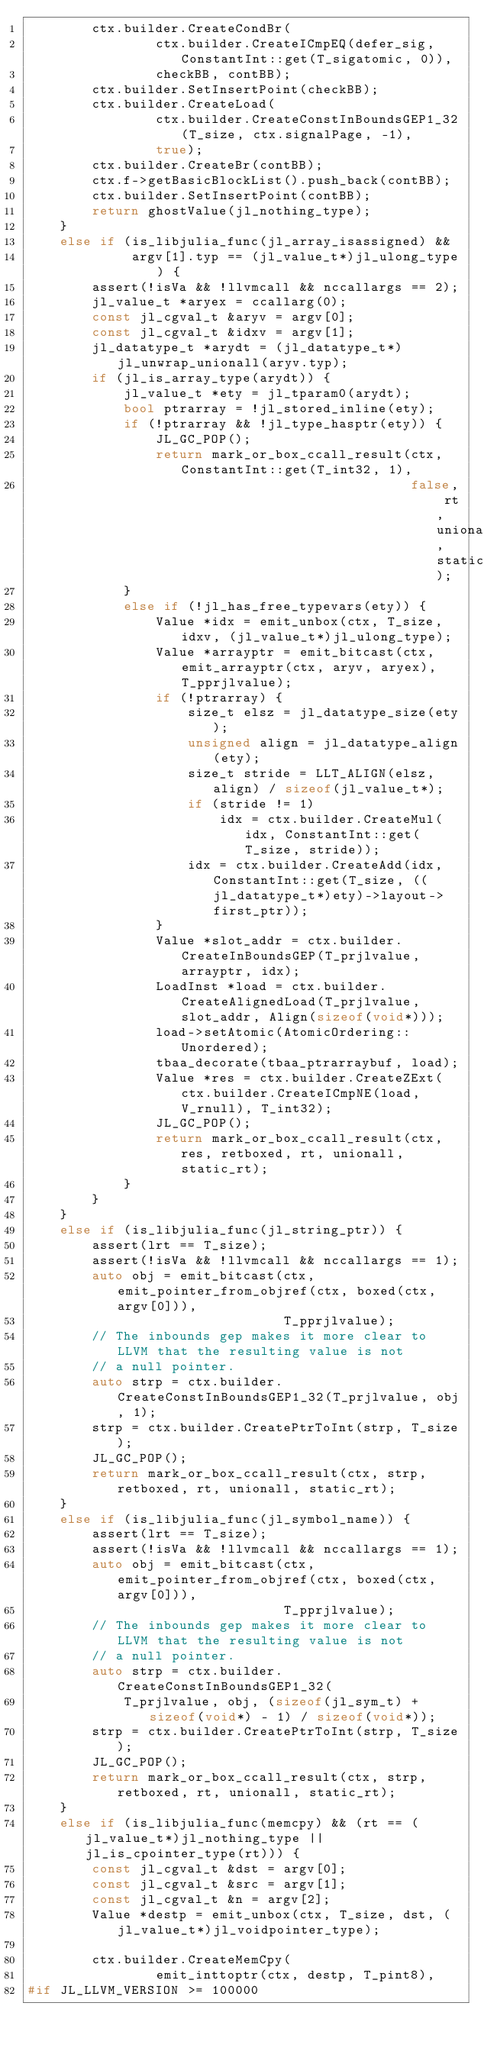<code> <loc_0><loc_0><loc_500><loc_500><_C++_>        ctx.builder.CreateCondBr(
                ctx.builder.CreateICmpEQ(defer_sig, ConstantInt::get(T_sigatomic, 0)),
                checkBB, contBB);
        ctx.builder.SetInsertPoint(checkBB);
        ctx.builder.CreateLoad(
                ctx.builder.CreateConstInBoundsGEP1_32(T_size, ctx.signalPage, -1),
                true);
        ctx.builder.CreateBr(contBB);
        ctx.f->getBasicBlockList().push_back(contBB);
        ctx.builder.SetInsertPoint(contBB);
        return ghostValue(jl_nothing_type);
    }
    else if (is_libjulia_func(jl_array_isassigned) &&
             argv[1].typ == (jl_value_t*)jl_ulong_type) {
        assert(!isVa && !llvmcall && nccallargs == 2);
        jl_value_t *aryex = ccallarg(0);
        const jl_cgval_t &aryv = argv[0];
        const jl_cgval_t &idxv = argv[1];
        jl_datatype_t *arydt = (jl_datatype_t*)jl_unwrap_unionall(aryv.typ);
        if (jl_is_array_type(arydt)) {
            jl_value_t *ety = jl_tparam0(arydt);
            bool ptrarray = !jl_stored_inline(ety);
            if (!ptrarray && !jl_type_hasptr(ety)) {
                JL_GC_POP();
                return mark_or_box_ccall_result(ctx, ConstantInt::get(T_int32, 1),
                                                false, rt, unionall, static_rt);
            }
            else if (!jl_has_free_typevars(ety)) {
                Value *idx = emit_unbox(ctx, T_size, idxv, (jl_value_t*)jl_ulong_type);
                Value *arrayptr = emit_bitcast(ctx, emit_arrayptr(ctx, aryv, aryex), T_pprjlvalue);
                if (!ptrarray) {
                    size_t elsz = jl_datatype_size(ety);
                    unsigned align = jl_datatype_align(ety);
                    size_t stride = LLT_ALIGN(elsz, align) / sizeof(jl_value_t*);
                    if (stride != 1)
                        idx = ctx.builder.CreateMul(idx, ConstantInt::get(T_size, stride));
                    idx = ctx.builder.CreateAdd(idx, ConstantInt::get(T_size, ((jl_datatype_t*)ety)->layout->first_ptr));
                }
                Value *slot_addr = ctx.builder.CreateInBoundsGEP(T_prjlvalue, arrayptr, idx);
                LoadInst *load = ctx.builder.CreateAlignedLoad(T_prjlvalue, slot_addr, Align(sizeof(void*)));
                load->setAtomic(AtomicOrdering::Unordered);
                tbaa_decorate(tbaa_ptrarraybuf, load);
                Value *res = ctx.builder.CreateZExt(ctx.builder.CreateICmpNE(load, V_rnull), T_int32);
                JL_GC_POP();
                return mark_or_box_ccall_result(ctx, res, retboxed, rt, unionall, static_rt);
            }
        }
    }
    else if (is_libjulia_func(jl_string_ptr)) {
        assert(lrt == T_size);
        assert(!isVa && !llvmcall && nccallargs == 1);
        auto obj = emit_bitcast(ctx, emit_pointer_from_objref(ctx, boxed(ctx, argv[0])),
                                T_pprjlvalue);
        // The inbounds gep makes it more clear to LLVM that the resulting value is not
        // a null pointer.
        auto strp = ctx.builder.CreateConstInBoundsGEP1_32(T_prjlvalue, obj, 1);
        strp = ctx.builder.CreatePtrToInt(strp, T_size);
        JL_GC_POP();
        return mark_or_box_ccall_result(ctx, strp, retboxed, rt, unionall, static_rt);
    }
    else if (is_libjulia_func(jl_symbol_name)) {
        assert(lrt == T_size);
        assert(!isVa && !llvmcall && nccallargs == 1);
        auto obj = emit_bitcast(ctx, emit_pointer_from_objref(ctx, boxed(ctx, argv[0])),
                                T_pprjlvalue);
        // The inbounds gep makes it more clear to LLVM that the resulting value is not
        // a null pointer.
        auto strp = ctx.builder.CreateConstInBoundsGEP1_32(
            T_prjlvalue, obj, (sizeof(jl_sym_t) + sizeof(void*) - 1) / sizeof(void*));
        strp = ctx.builder.CreatePtrToInt(strp, T_size);
        JL_GC_POP();
        return mark_or_box_ccall_result(ctx, strp, retboxed, rt, unionall, static_rt);
    }
    else if (is_libjulia_func(memcpy) && (rt == (jl_value_t*)jl_nothing_type || jl_is_cpointer_type(rt))) {
        const jl_cgval_t &dst = argv[0];
        const jl_cgval_t &src = argv[1];
        const jl_cgval_t &n = argv[2];
        Value *destp = emit_unbox(ctx, T_size, dst, (jl_value_t*)jl_voidpointer_type);

        ctx.builder.CreateMemCpy(
                emit_inttoptr(ctx, destp, T_pint8),
#if JL_LLVM_VERSION >= 100000</code> 